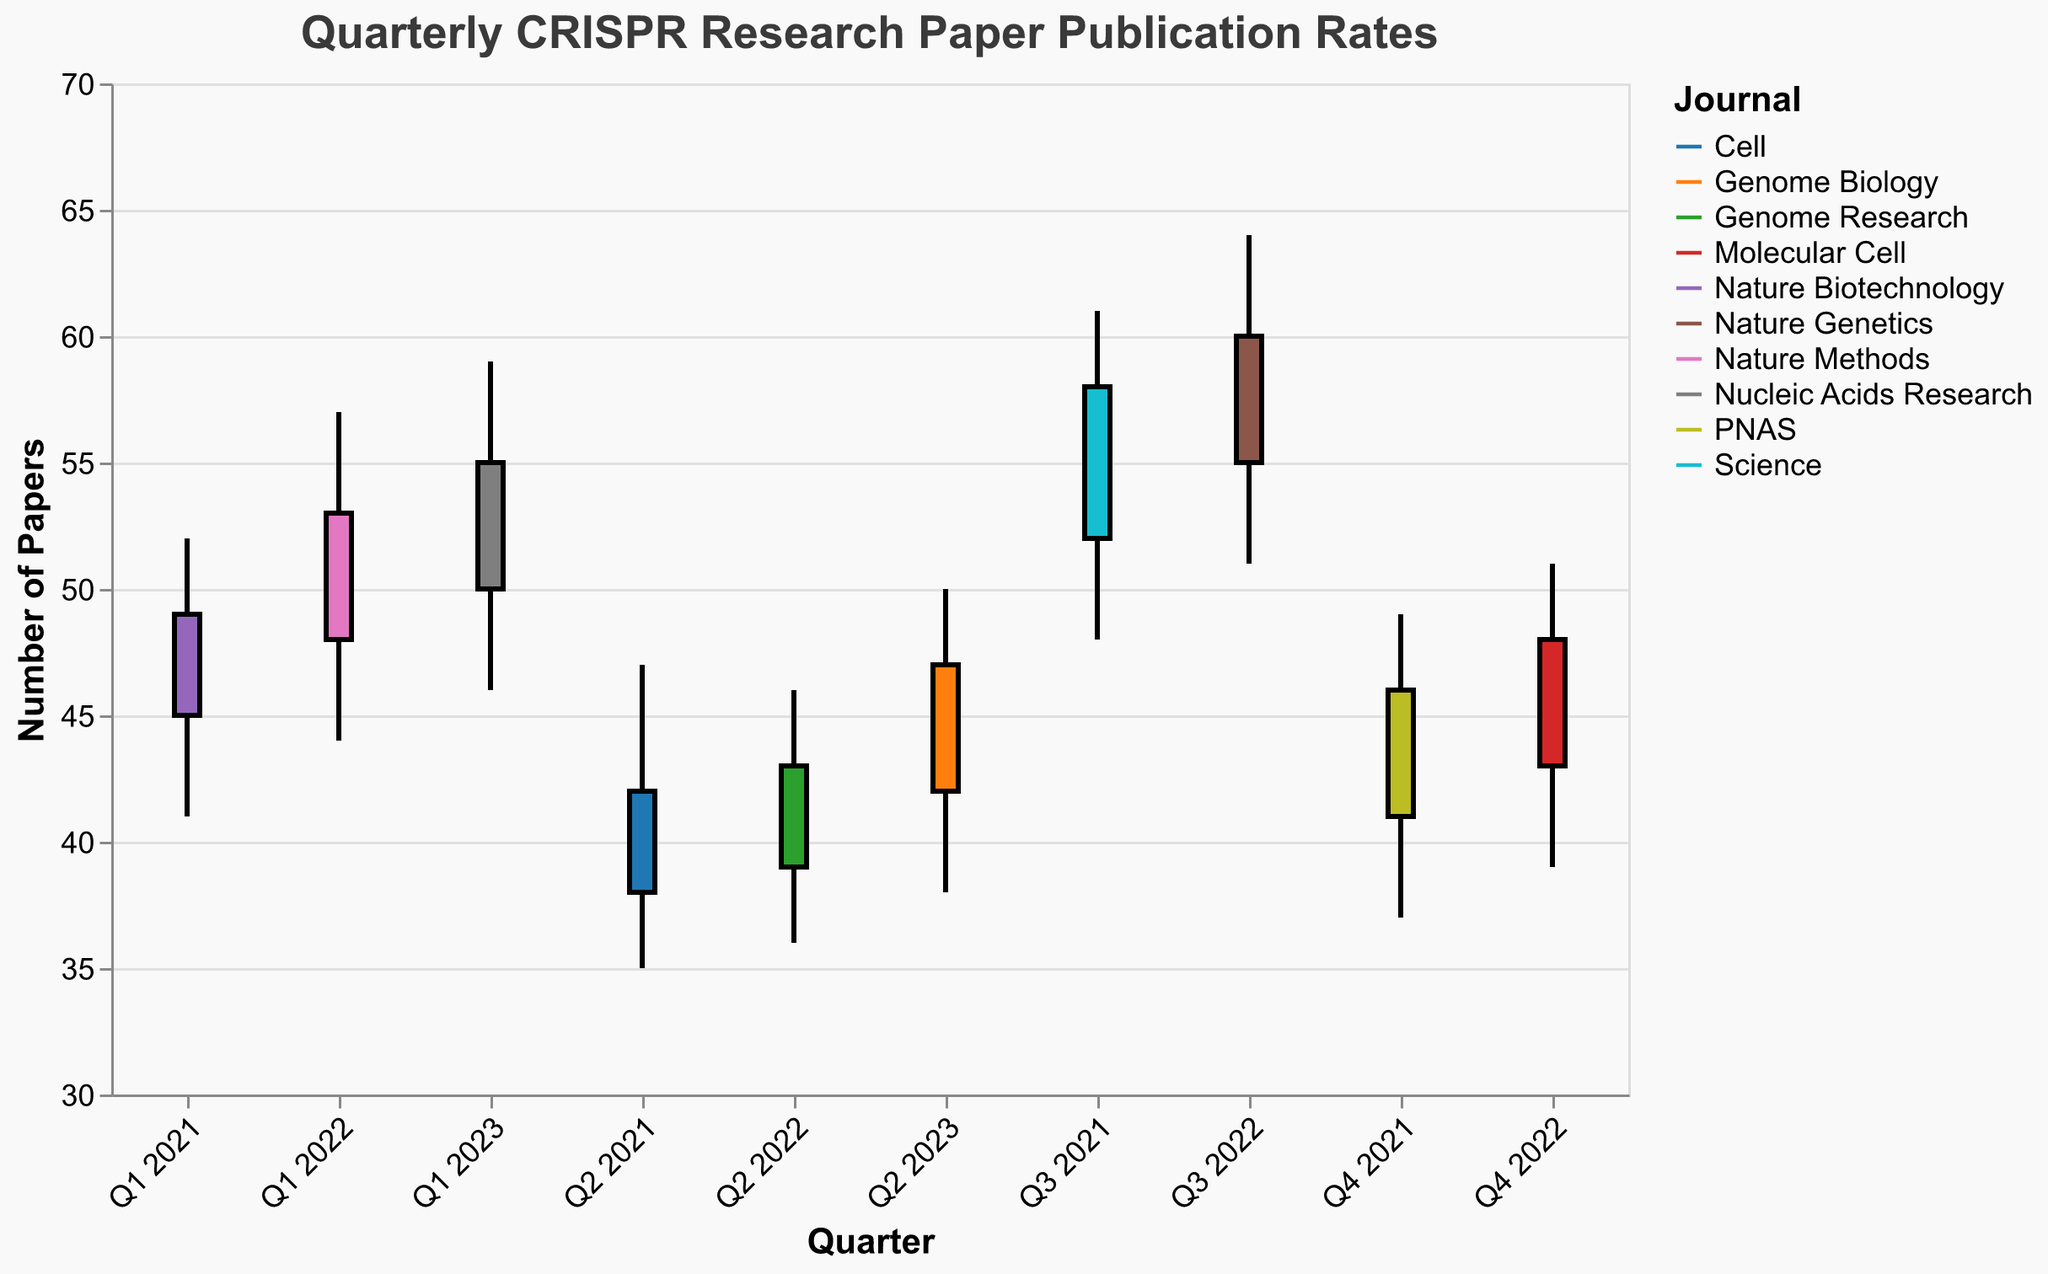What is the title of the figure? The title is located at the top of the figure in a larger font size.
Answer: Quarterly CRISPR Research Paper Publication Rates Which quarter and journal combination has the highest high value? Look at the high values and the corresponding quarters and journals. The highest value is 64 in Q3 2022 for Nature Genetics.
Answer: Q3 2022, Nature Genetics How many scientific journals are included in the figure? Each colored line represents a different journal in the legend, count the unique entries in the legend.
Answer: 10 What was the closing value for Q1 2023 in Nucleic Acids Research? Identify the quarter Q1 2023 and the journal Nucleic Acids Research. Find the close value.
Answer: 55 What is the average close value for Science in Q3 2021 and Nucleic Acids Research in Q1 2023? The close values are 58 and 55. Calculate the average: (58 + 55) / 2.
Answer: 56.5 Which journal had the lowest low value and in which quarter? Compare the low values across all quarters and journals. The lowest value is 35 for Cell in Q2 2021.
Answer: Cell, Q2 2021 What was the difference between the high and low values for Nature Methods in Q1 2022? Identify the high and low values for Q1 2022 in Nature Methods. Subtract the low value from the high value: 57 - 44.
Answer: 13 Which quarter had the smallest range between the high and low values? Calculate the range (High - Low) for each quarter and identify the smallest one. The smallest range is 9 for Q2 2023 (50-38=9).
Answer: Q2 2023 How many more papers were accepted than rejected in Genome Research in Q2 2022? Identify the accepted and rejected values for Genome Research in Q2 2022. Subtract the rejected value from the accepted value: 33 - 13.
Answer: 20 Between Q1 2021 and Q2 2023, which quarter has the maximum opening value? Compare the opening values across all quarters. The maximum opening value is 55 in Q3 2022.
Answer: Q3 2022 